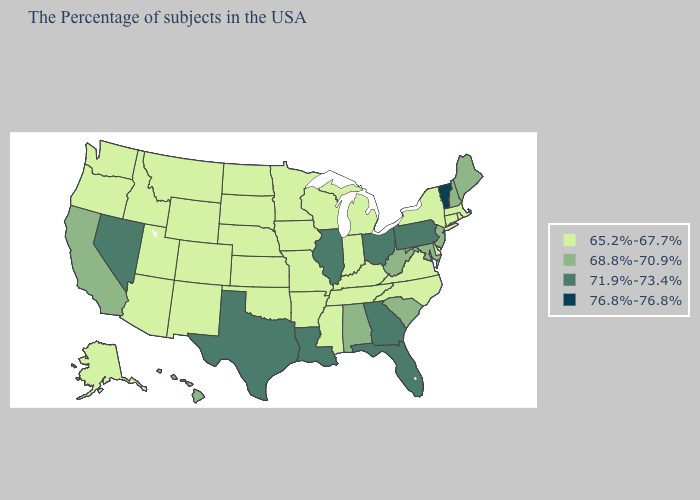Does Utah have a lower value than Minnesota?
Be succinct. No. Among the states that border Ohio , does Indiana have the lowest value?
Give a very brief answer. Yes. Name the states that have a value in the range 76.8%-76.8%?
Give a very brief answer. Vermont. Name the states that have a value in the range 76.8%-76.8%?
Concise answer only. Vermont. Name the states that have a value in the range 71.9%-73.4%?
Give a very brief answer. Pennsylvania, Ohio, Florida, Georgia, Illinois, Louisiana, Texas, Nevada. What is the lowest value in the South?
Short answer required. 65.2%-67.7%. Does New York have the same value as Indiana?
Answer briefly. Yes. Does Illinois have the highest value in the MidWest?
Quick response, please. Yes. Name the states that have a value in the range 76.8%-76.8%?
Answer briefly. Vermont. Does Montana have the highest value in the USA?
Answer briefly. No. Name the states that have a value in the range 65.2%-67.7%?
Write a very short answer. Massachusetts, Rhode Island, Connecticut, New York, Delaware, Virginia, North Carolina, Michigan, Kentucky, Indiana, Tennessee, Wisconsin, Mississippi, Missouri, Arkansas, Minnesota, Iowa, Kansas, Nebraska, Oklahoma, South Dakota, North Dakota, Wyoming, Colorado, New Mexico, Utah, Montana, Arizona, Idaho, Washington, Oregon, Alaska. What is the highest value in the USA?
Quick response, please. 76.8%-76.8%. Does Kentucky have the same value as Montana?
Answer briefly. Yes. Among the states that border Ohio , does Pennsylvania have the highest value?
Keep it brief. Yes. What is the value of California?
Write a very short answer. 68.8%-70.9%. 